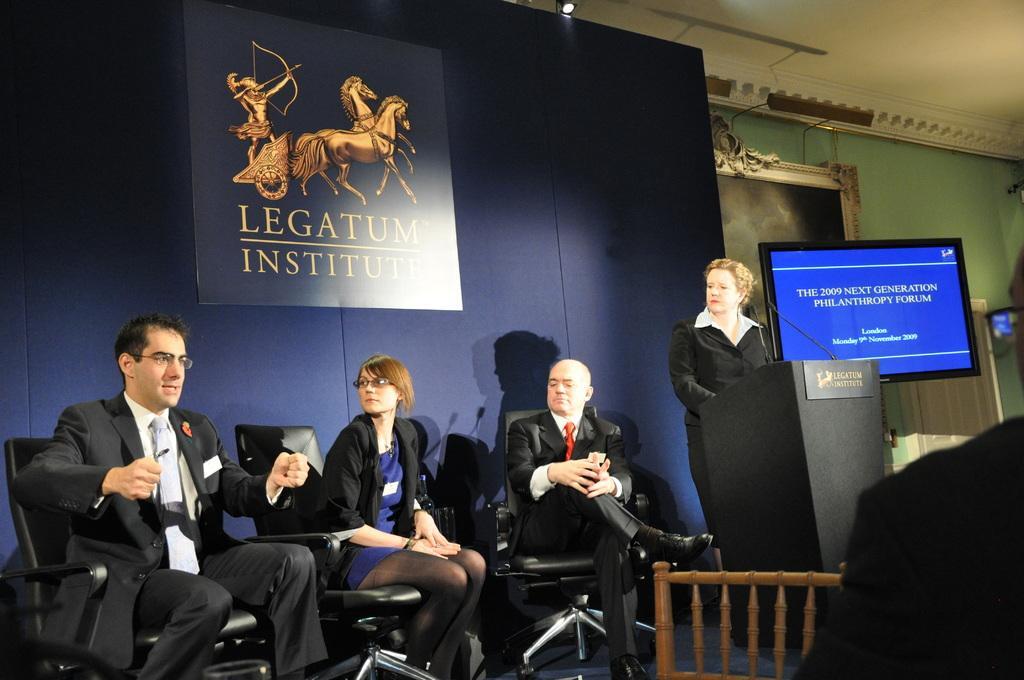Can you describe this image briefly? In this image on a stage three people are sitting on chairs. One lady is standing beside The podium. Person on the left is talking. There is a screen bedside the podium. There is a fence around the stage. In the background there is wall, poster,curtains. 